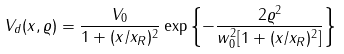<formula> <loc_0><loc_0><loc_500><loc_500>V _ { d } ( x , \varrho ) = \frac { V _ { 0 } } { 1 + ( x / x _ { R } ) ^ { 2 } } \exp \left \{ - \frac { 2 \varrho ^ { 2 } } { w _ { 0 } ^ { 2 } [ 1 + ( x / x _ { R } ) ^ { 2 } ] } \right \}</formula> 